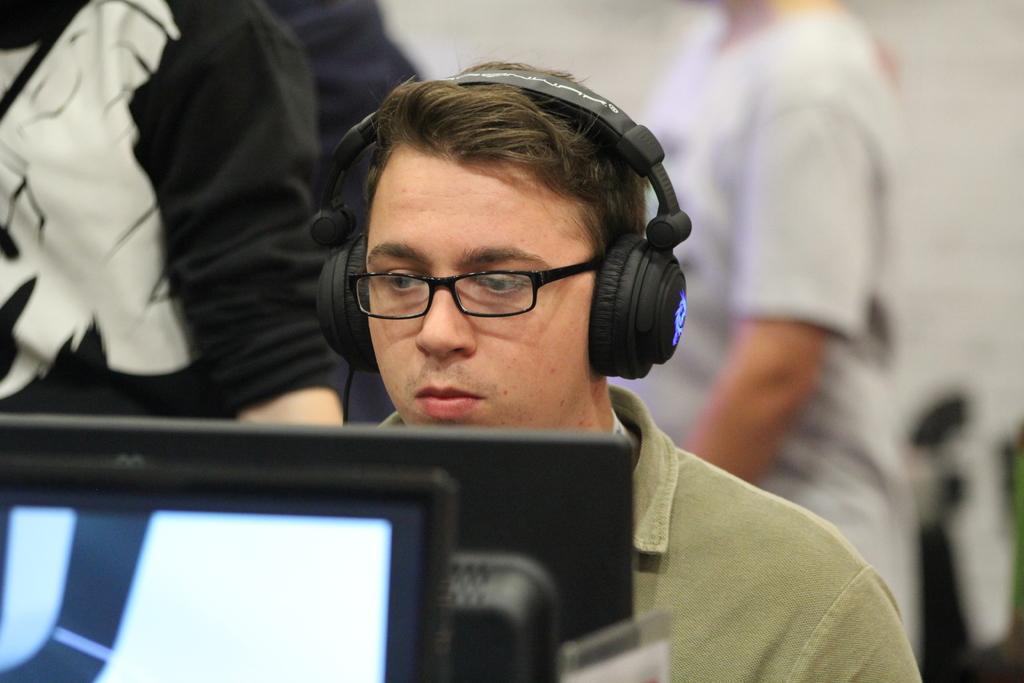Can you describe this image briefly? In this image there is a person wearing headphones is looking into a monitor in front of him, behind the person there are few other people walking. 